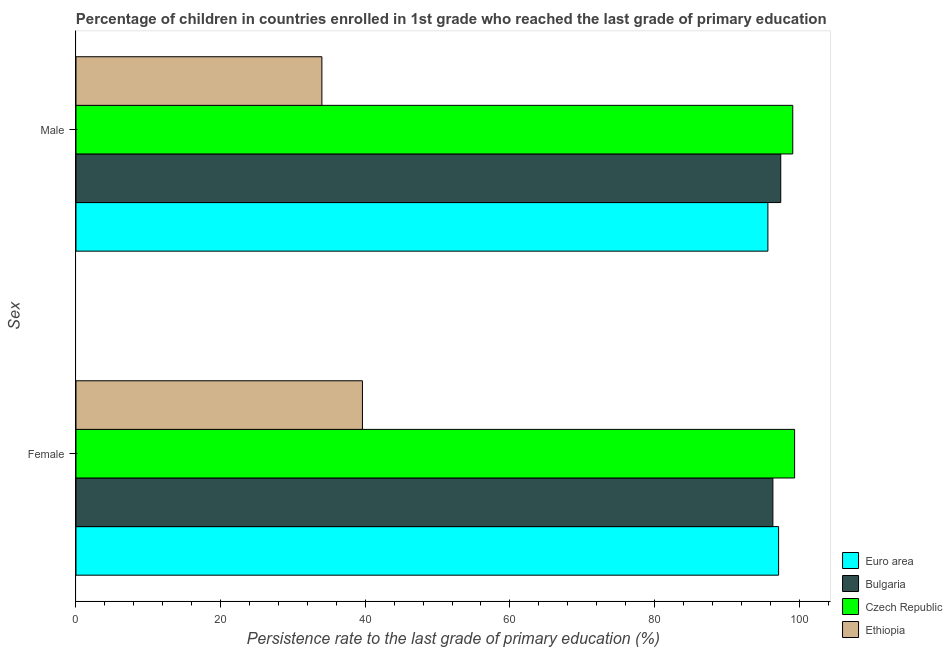Are the number of bars per tick equal to the number of legend labels?
Offer a terse response. Yes. Are the number of bars on each tick of the Y-axis equal?
Offer a terse response. Yes. How many bars are there on the 1st tick from the bottom?
Make the answer very short. 4. What is the label of the 2nd group of bars from the top?
Your answer should be very brief. Female. What is the persistence rate of male students in Euro area?
Give a very brief answer. 95.69. Across all countries, what is the maximum persistence rate of female students?
Your answer should be very brief. 99.38. Across all countries, what is the minimum persistence rate of male students?
Make the answer very short. 34.01. In which country was the persistence rate of female students maximum?
Make the answer very short. Czech Republic. In which country was the persistence rate of female students minimum?
Your response must be concise. Ethiopia. What is the total persistence rate of male students in the graph?
Your response must be concise. 326.29. What is the difference between the persistence rate of female students in Euro area and that in Bulgaria?
Offer a terse response. 0.79. What is the difference between the persistence rate of female students in Euro area and the persistence rate of male students in Bulgaria?
Make the answer very short. -0.3. What is the average persistence rate of male students per country?
Your answer should be compact. 81.57. What is the difference between the persistence rate of female students and persistence rate of male students in Euro area?
Offer a terse response. 1.48. In how many countries, is the persistence rate of female students greater than 40 %?
Provide a short and direct response. 3. What is the ratio of the persistence rate of female students in Czech Republic to that in Bulgaria?
Offer a terse response. 1.03. In how many countries, is the persistence rate of male students greater than the average persistence rate of male students taken over all countries?
Offer a terse response. 3. What does the 4th bar from the top in Male represents?
Your answer should be compact. Euro area. How many bars are there?
Your answer should be compact. 8. How many countries are there in the graph?
Ensure brevity in your answer.  4. How many legend labels are there?
Provide a short and direct response. 4. What is the title of the graph?
Ensure brevity in your answer.  Percentage of children in countries enrolled in 1st grade who reached the last grade of primary education. What is the label or title of the X-axis?
Your answer should be compact. Persistence rate to the last grade of primary education (%). What is the label or title of the Y-axis?
Your response must be concise. Sex. What is the Persistence rate to the last grade of primary education (%) in Euro area in Female?
Make the answer very short. 97.17. What is the Persistence rate to the last grade of primary education (%) of Bulgaria in Female?
Offer a terse response. 96.38. What is the Persistence rate to the last grade of primary education (%) of Czech Republic in Female?
Provide a succinct answer. 99.38. What is the Persistence rate to the last grade of primary education (%) of Ethiopia in Female?
Keep it short and to the point. 39.61. What is the Persistence rate to the last grade of primary education (%) in Euro area in Male?
Your answer should be compact. 95.69. What is the Persistence rate to the last grade of primary education (%) in Bulgaria in Male?
Provide a short and direct response. 97.47. What is the Persistence rate to the last grade of primary education (%) of Czech Republic in Male?
Offer a terse response. 99.13. What is the Persistence rate to the last grade of primary education (%) in Ethiopia in Male?
Your answer should be very brief. 34.01. Across all Sex, what is the maximum Persistence rate to the last grade of primary education (%) of Euro area?
Give a very brief answer. 97.17. Across all Sex, what is the maximum Persistence rate to the last grade of primary education (%) in Bulgaria?
Offer a very short reply. 97.47. Across all Sex, what is the maximum Persistence rate to the last grade of primary education (%) in Czech Republic?
Provide a succinct answer. 99.38. Across all Sex, what is the maximum Persistence rate to the last grade of primary education (%) of Ethiopia?
Your response must be concise. 39.61. Across all Sex, what is the minimum Persistence rate to the last grade of primary education (%) of Euro area?
Your answer should be very brief. 95.69. Across all Sex, what is the minimum Persistence rate to the last grade of primary education (%) in Bulgaria?
Your answer should be compact. 96.38. Across all Sex, what is the minimum Persistence rate to the last grade of primary education (%) in Czech Republic?
Your answer should be very brief. 99.13. Across all Sex, what is the minimum Persistence rate to the last grade of primary education (%) in Ethiopia?
Offer a very short reply. 34.01. What is the total Persistence rate to the last grade of primary education (%) of Euro area in the graph?
Provide a short and direct response. 192.86. What is the total Persistence rate to the last grade of primary education (%) of Bulgaria in the graph?
Make the answer very short. 193.84. What is the total Persistence rate to the last grade of primary education (%) of Czech Republic in the graph?
Provide a succinct answer. 198.51. What is the total Persistence rate to the last grade of primary education (%) of Ethiopia in the graph?
Offer a terse response. 73.62. What is the difference between the Persistence rate to the last grade of primary education (%) of Euro area in Female and that in Male?
Give a very brief answer. 1.48. What is the difference between the Persistence rate to the last grade of primary education (%) in Bulgaria in Female and that in Male?
Your response must be concise. -1.09. What is the difference between the Persistence rate to the last grade of primary education (%) in Czech Republic in Female and that in Male?
Provide a succinct answer. 0.26. What is the difference between the Persistence rate to the last grade of primary education (%) of Ethiopia in Female and that in Male?
Keep it short and to the point. 5.61. What is the difference between the Persistence rate to the last grade of primary education (%) of Euro area in Female and the Persistence rate to the last grade of primary education (%) of Bulgaria in Male?
Make the answer very short. -0.3. What is the difference between the Persistence rate to the last grade of primary education (%) of Euro area in Female and the Persistence rate to the last grade of primary education (%) of Czech Republic in Male?
Offer a terse response. -1.96. What is the difference between the Persistence rate to the last grade of primary education (%) of Euro area in Female and the Persistence rate to the last grade of primary education (%) of Ethiopia in Male?
Make the answer very short. 63.16. What is the difference between the Persistence rate to the last grade of primary education (%) in Bulgaria in Female and the Persistence rate to the last grade of primary education (%) in Czech Republic in Male?
Make the answer very short. -2.75. What is the difference between the Persistence rate to the last grade of primary education (%) in Bulgaria in Female and the Persistence rate to the last grade of primary education (%) in Ethiopia in Male?
Keep it short and to the point. 62.37. What is the difference between the Persistence rate to the last grade of primary education (%) of Czech Republic in Female and the Persistence rate to the last grade of primary education (%) of Ethiopia in Male?
Offer a terse response. 65.38. What is the average Persistence rate to the last grade of primary education (%) of Euro area per Sex?
Provide a succinct answer. 96.43. What is the average Persistence rate to the last grade of primary education (%) of Bulgaria per Sex?
Your answer should be very brief. 96.92. What is the average Persistence rate to the last grade of primary education (%) in Czech Republic per Sex?
Provide a succinct answer. 99.25. What is the average Persistence rate to the last grade of primary education (%) of Ethiopia per Sex?
Make the answer very short. 36.81. What is the difference between the Persistence rate to the last grade of primary education (%) in Euro area and Persistence rate to the last grade of primary education (%) in Bulgaria in Female?
Offer a very short reply. 0.79. What is the difference between the Persistence rate to the last grade of primary education (%) of Euro area and Persistence rate to the last grade of primary education (%) of Czech Republic in Female?
Offer a very short reply. -2.21. What is the difference between the Persistence rate to the last grade of primary education (%) of Euro area and Persistence rate to the last grade of primary education (%) of Ethiopia in Female?
Offer a very short reply. 57.55. What is the difference between the Persistence rate to the last grade of primary education (%) in Bulgaria and Persistence rate to the last grade of primary education (%) in Czech Republic in Female?
Provide a short and direct response. -3. What is the difference between the Persistence rate to the last grade of primary education (%) of Bulgaria and Persistence rate to the last grade of primary education (%) of Ethiopia in Female?
Your answer should be compact. 56.76. What is the difference between the Persistence rate to the last grade of primary education (%) of Czech Republic and Persistence rate to the last grade of primary education (%) of Ethiopia in Female?
Your response must be concise. 59.77. What is the difference between the Persistence rate to the last grade of primary education (%) in Euro area and Persistence rate to the last grade of primary education (%) in Bulgaria in Male?
Ensure brevity in your answer.  -1.78. What is the difference between the Persistence rate to the last grade of primary education (%) in Euro area and Persistence rate to the last grade of primary education (%) in Czech Republic in Male?
Ensure brevity in your answer.  -3.44. What is the difference between the Persistence rate to the last grade of primary education (%) of Euro area and Persistence rate to the last grade of primary education (%) of Ethiopia in Male?
Give a very brief answer. 61.68. What is the difference between the Persistence rate to the last grade of primary education (%) of Bulgaria and Persistence rate to the last grade of primary education (%) of Czech Republic in Male?
Provide a succinct answer. -1.66. What is the difference between the Persistence rate to the last grade of primary education (%) in Bulgaria and Persistence rate to the last grade of primary education (%) in Ethiopia in Male?
Make the answer very short. 63.46. What is the difference between the Persistence rate to the last grade of primary education (%) of Czech Republic and Persistence rate to the last grade of primary education (%) of Ethiopia in Male?
Keep it short and to the point. 65.12. What is the ratio of the Persistence rate to the last grade of primary education (%) in Euro area in Female to that in Male?
Offer a very short reply. 1.02. What is the ratio of the Persistence rate to the last grade of primary education (%) in Bulgaria in Female to that in Male?
Your answer should be very brief. 0.99. What is the ratio of the Persistence rate to the last grade of primary education (%) of Ethiopia in Female to that in Male?
Give a very brief answer. 1.16. What is the difference between the highest and the second highest Persistence rate to the last grade of primary education (%) of Euro area?
Make the answer very short. 1.48. What is the difference between the highest and the second highest Persistence rate to the last grade of primary education (%) of Bulgaria?
Provide a short and direct response. 1.09. What is the difference between the highest and the second highest Persistence rate to the last grade of primary education (%) in Czech Republic?
Ensure brevity in your answer.  0.26. What is the difference between the highest and the second highest Persistence rate to the last grade of primary education (%) of Ethiopia?
Your response must be concise. 5.61. What is the difference between the highest and the lowest Persistence rate to the last grade of primary education (%) of Euro area?
Ensure brevity in your answer.  1.48. What is the difference between the highest and the lowest Persistence rate to the last grade of primary education (%) in Bulgaria?
Your response must be concise. 1.09. What is the difference between the highest and the lowest Persistence rate to the last grade of primary education (%) in Czech Republic?
Ensure brevity in your answer.  0.26. What is the difference between the highest and the lowest Persistence rate to the last grade of primary education (%) of Ethiopia?
Your response must be concise. 5.61. 